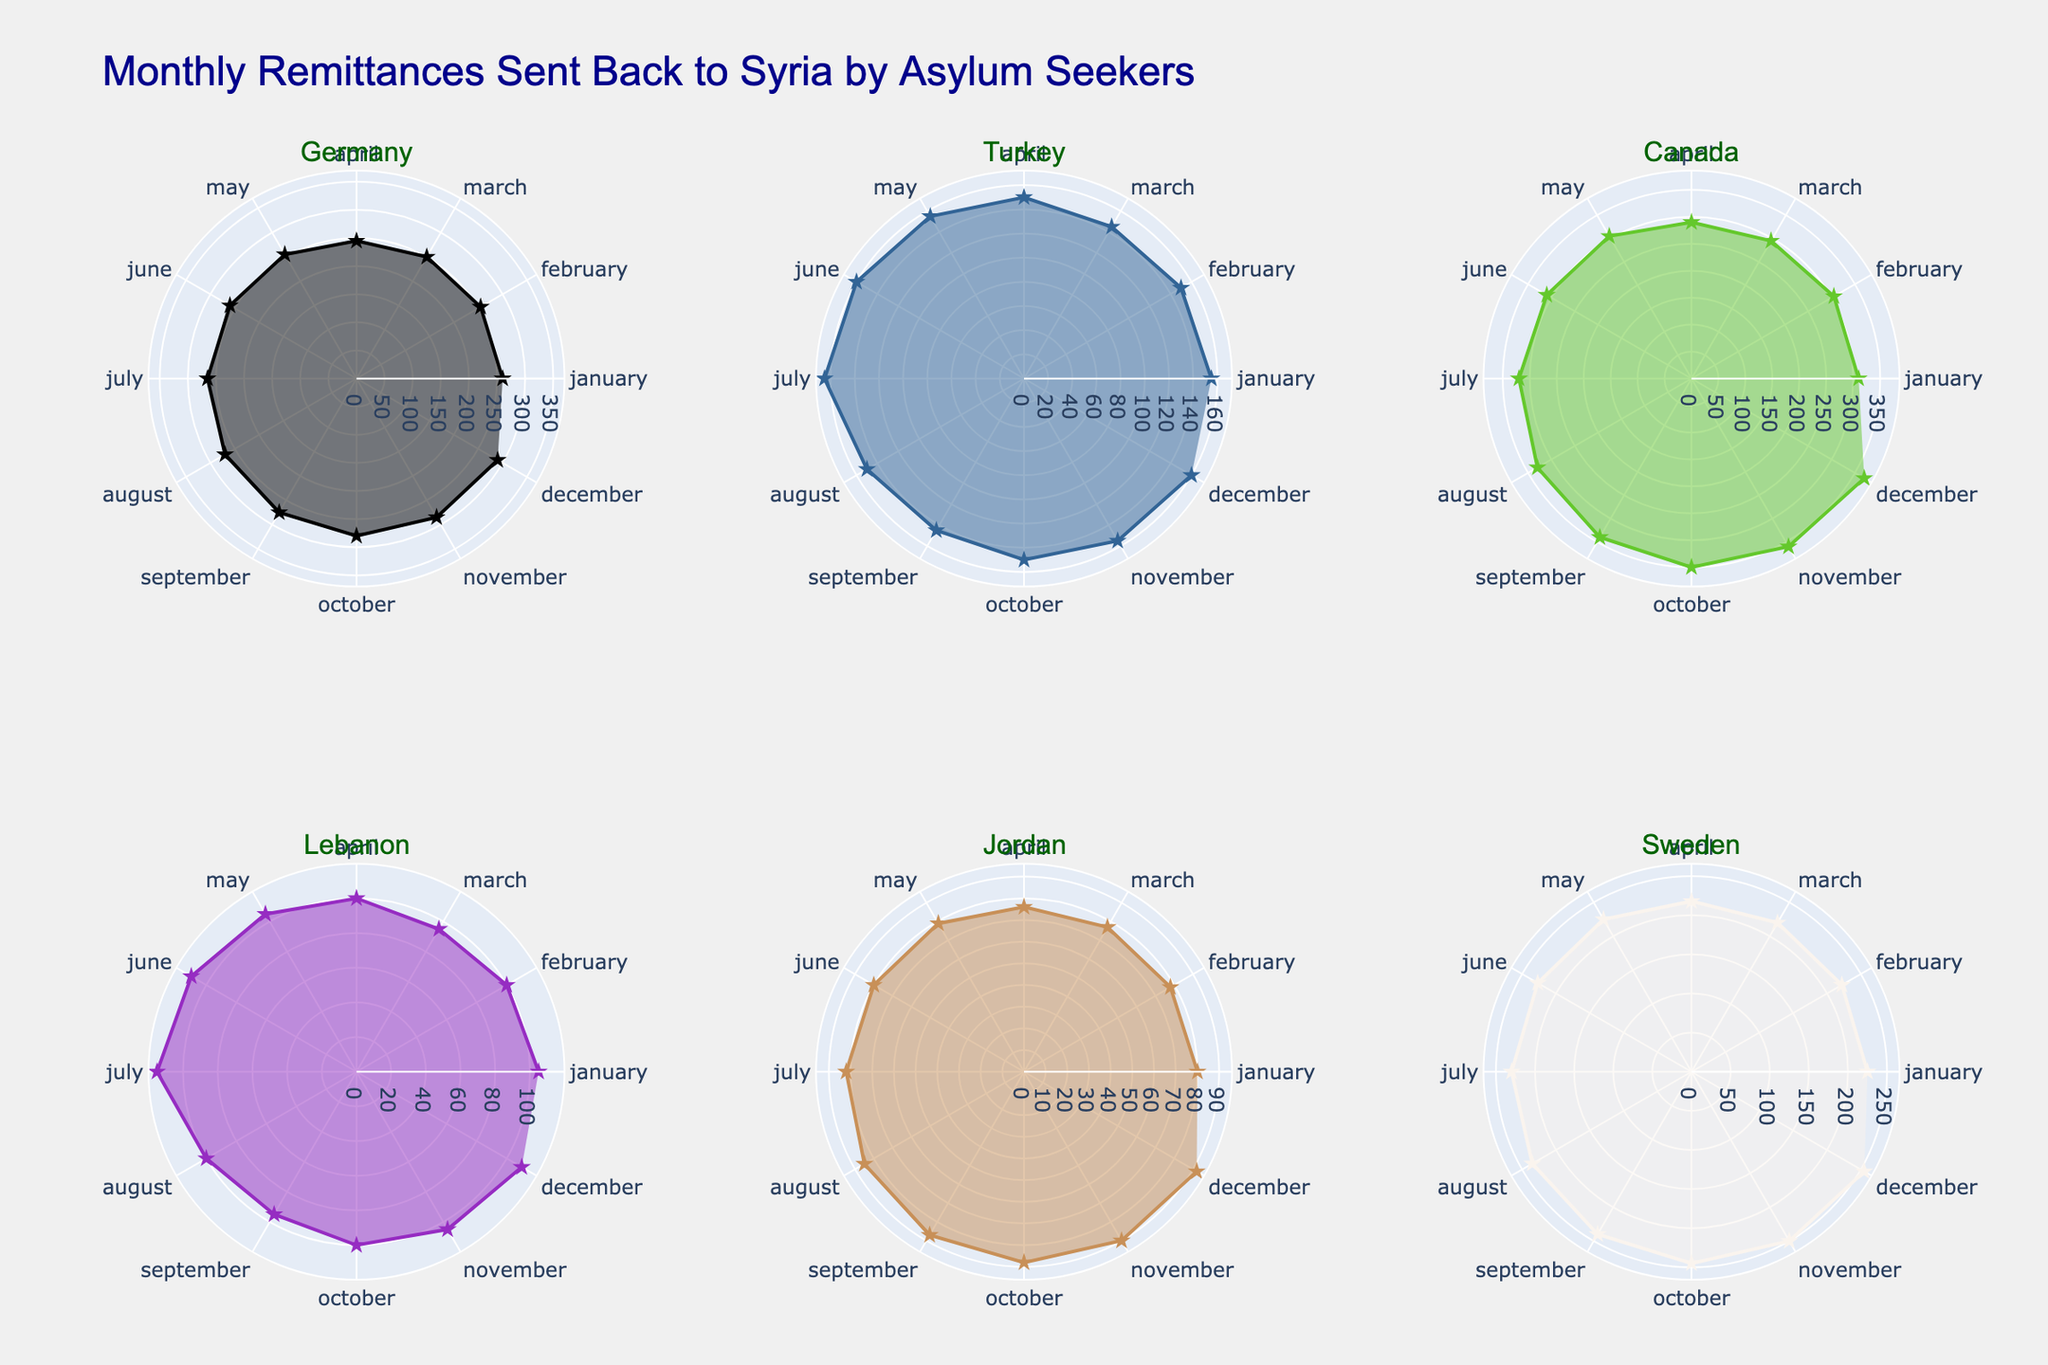what is the title of the figure? The title of the figure is located at the top and is often the most prominent text.
Answer: Monthly Remittances Sent Back to Syria by Asylum Seekers In which months does Germany have the highest remittances? By analyzing the data points on the polar chart for Germany, the highest values are in December.
Answer: December Which country has the lowest average remittance per month? By comparing the six subplots, identify the country with the smallest radial values.
Answer: Jordan What is the remittance value sent from Canada in November? Locate Canada’s subplot, find the point corresponding to November, and read the value from the chart.
Answer: 360 USD How many remittance data points are there for Lebanon? Each country's subplot has a data point for every month, so count them for Lebanon.
Answer: 12 Which two countries show the most significant increase in remittances between April and May? Compare the values of April and May for each country and find which have the largest differences.
Answer: Germany and Sweden What is the difference between Germany's and Turkey's remittances in September? Find the remittance values for Germany and Turkey in September from their respective subplots and subtract Turkey's value from Germany's.
Answer: 130 USD Which country shows the most stable remittance pattern throughout the year? Identify the country with the least variation between its maximum and minimum remittance values across all months in its subplot.
Answer: Jordan In which month does Sweden exceed 250 USD in remittances for the first time? Look for the first instance in Sweden's subplot where the value exceeds 250 USD and identify the corresponding month.
Answer: December What is the average remittance sent by asylum seekers in January across all countries? Add up the January remittance values from each subplot and divide by the number of countries (6).
Answer: 189.17 USD 